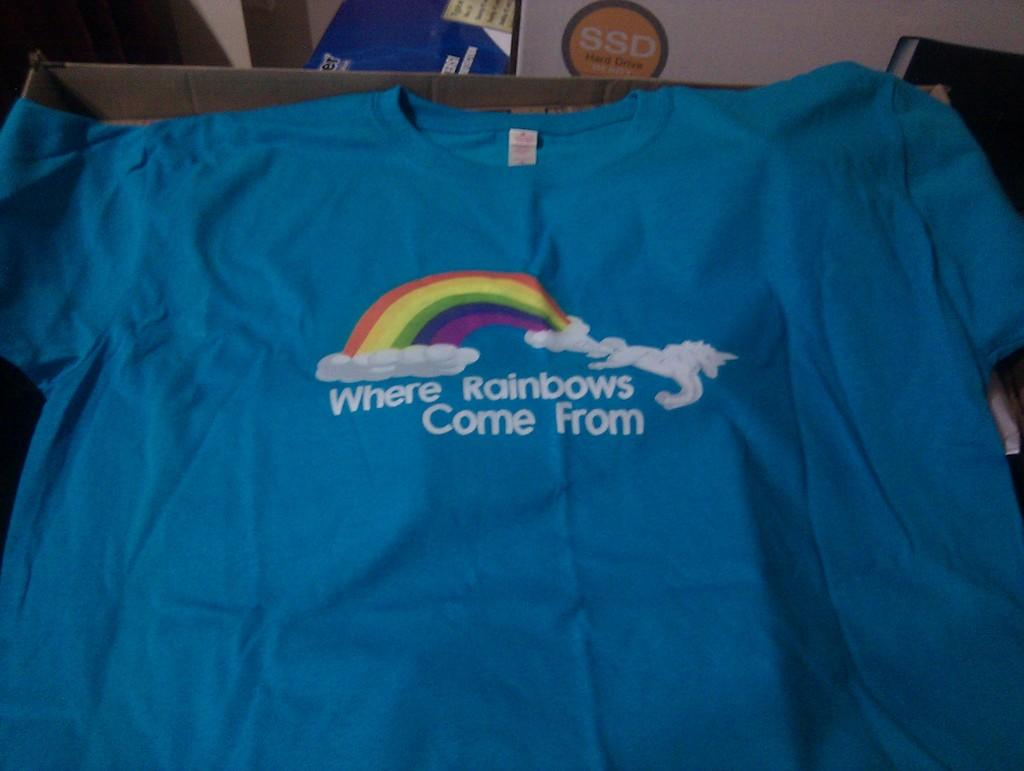Provide a one-sentence caption for the provided image. A tshirt with the words Where Rainbows Come From on it. 